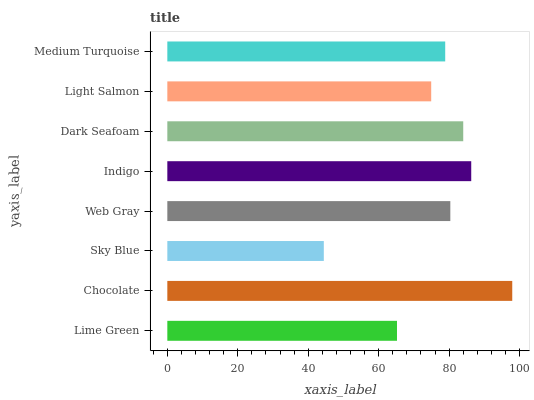Is Sky Blue the minimum?
Answer yes or no. Yes. Is Chocolate the maximum?
Answer yes or no. Yes. Is Chocolate the minimum?
Answer yes or no. No. Is Sky Blue the maximum?
Answer yes or no. No. Is Chocolate greater than Sky Blue?
Answer yes or no. Yes. Is Sky Blue less than Chocolate?
Answer yes or no. Yes. Is Sky Blue greater than Chocolate?
Answer yes or no. No. Is Chocolate less than Sky Blue?
Answer yes or no. No. Is Web Gray the high median?
Answer yes or no. Yes. Is Medium Turquoise the low median?
Answer yes or no. Yes. Is Chocolate the high median?
Answer yes or no. No. Is Dark Seafoam the low median?
Answer yes or no. No. 